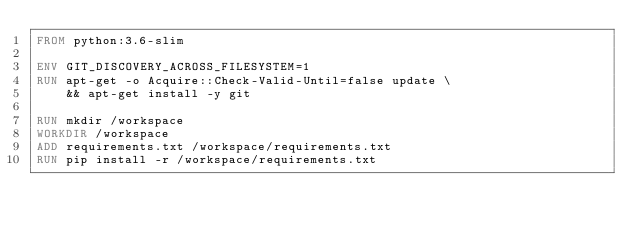<code> <loc_0><loc_0><loc_500><loc_500><_Dockerfile_>FROM python:3.6-slim

ENV GIT_DISCOVERY_ACROSS_FILESYSTEM=1
RUN apt-get -o Acquire::Check-Valid-Until=false update \
    && apt-get install -y git

RUN mkdir /workspace
WORKDIR /workspace
ADD requirements.txt /workspace/requirements.txt
RUN pip install -r /workspace/requirements.txt
</code> 